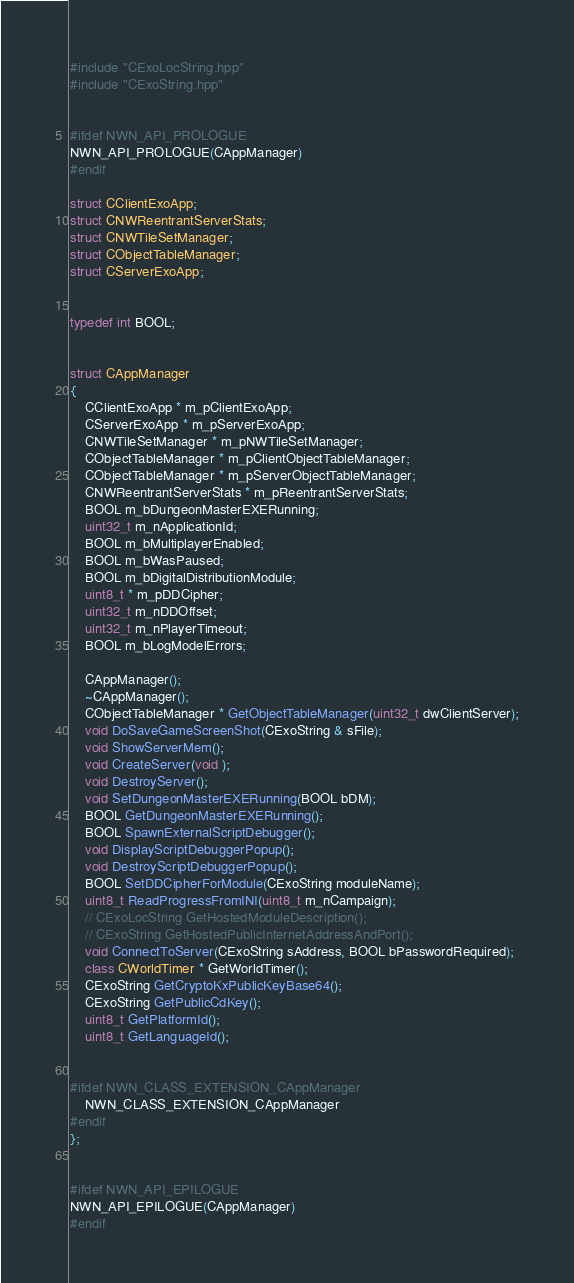Convert code to text. <code><loc_0><loc_0><loc_500><loc_500><_C++_>
#include "CExoLocString.hpp"
#include "CExoString.hpp"


#ifdef NWN_API_PROLOGUE
NWN_API_PROLOGUE(CAppManager)
#endif

struct CClientExoApp;
struct CNWReentrantServerStats;
struct CNWTileSetManager;
struct CObjectTableManager;
struct CServerExoApp;


typedef int BOOL;


struct CAppManager
{
    CClientExoApp * m_pClientExoApp;
    CServerExoApp * m_pServerExoApp;
    CNWTileSetManager * m_pNWTileSetManager;
    CObjectTableManager * m_pClientObjectTableManager;
    CObjectTableManager * m_pServerObjectTableManager;
    CNWReentrantServerStats * m_pReentrantServerStats;
    BOOL m_bDungeonMasterEXERunning;
    uint32_t m_nApplicationId;
    BOOL m_bMultiplayerEnabled;
    BOOL m_bWasPaused;
    BOOL m_bDigitalDistributionModule;
    uint8_t * m_pDDCipher;
    uint32_t m_nDDOffset;
    uint32_t m_nPlayerTimeout;
    BOOL m_bLogModelErrors;

    CAppManager();
    ~CAppManager();
    CObjectTableManager * GetObjectTableManager(uint32_t dwClientServer);
    void DoSaveGameScreenShot(CExoString & sFile);
    void ShowServerMem();
    void CreateServer(void );
    void DestroyServer();
    void SetDungeonMasterEXERunning(BOOL bDM);
    BOOL GetDungeonMasterEXERunning();
    BOOL SpawnExternalScriptDebugger();
    void DisplayScriptDebuggerPopup();
    void DestroyScriptDebuggerPopup();
    BOOL SetDDCipherForModule(CExoString moduleName);
    uint8_t ReadProgressFromINI(uint8_t m_nCampaign);
    // CExoLocString GetHostedModuleDescription();
    // CExoString GetHostedPublicInternetAddressAndPort();
    void ConnectToServer(CExoString sAddress, BOOL bPasswordRequired);
    class CWorldTimer * GetWorldTimer();
    CExoString GetCryptoKxPublicKeyBase64();
    CExoString GetPublicCdKey();
    uint8_t GetPlatformId();
    uint8_t GetLanguageId();


#ifdef NWN_CLASS_EXTENSION_CAppManager
    NWN_CLASS_EXTENSION_CAppManager
#endif
};


#ifdef NWN_API_EPILOGUE
NWN_API_EPILOGUE(CAppManager)
#endif

</code> 